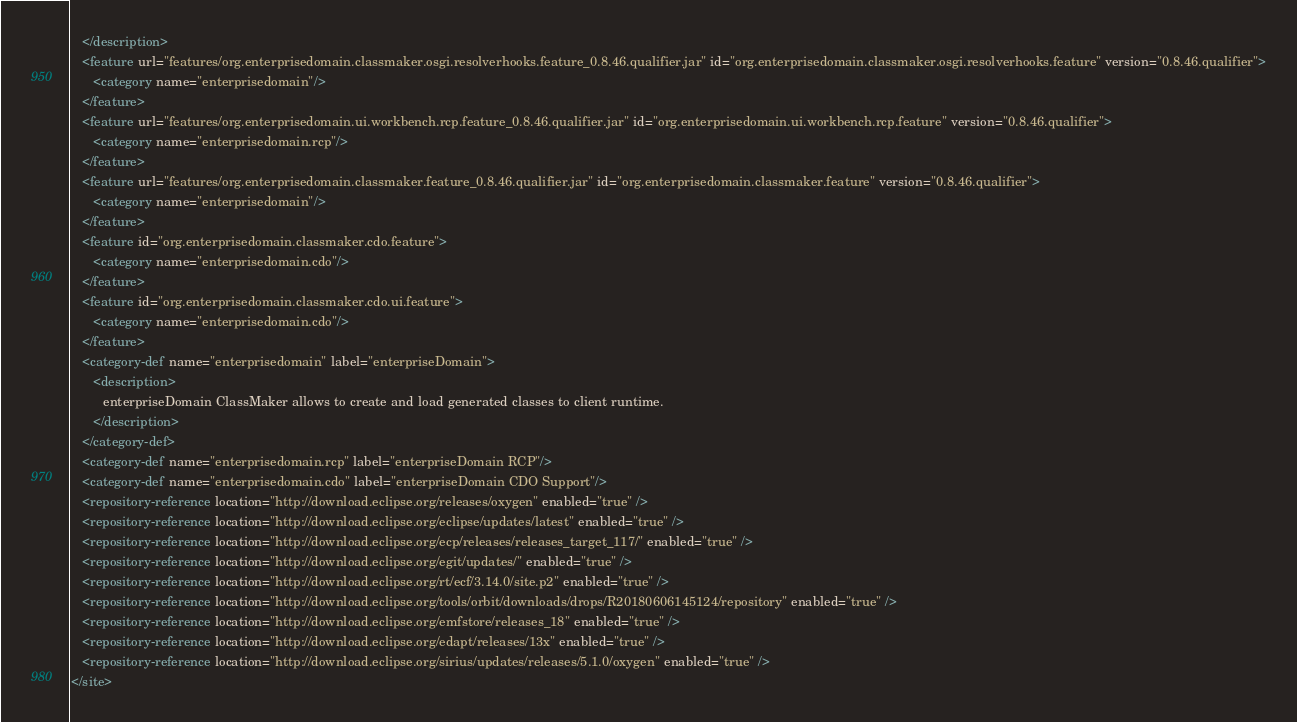Convert code to text. <code><loc_0><loc_0><loc_500><loc_500><_XML_>   </description>
   <feature url="features/org.enterprisedomain.classmaker.osgi.resolverhooks.feature_0.8.46.qualifier.jar" id="org.enterprisedomain.classmaker.osgi.resolverhooks.feature" version="0.8.46.qualifier">
      <category name="enterprisedomain"/>
   </feature>
   <feature url="features/org.enterprisedomain.ui.workbench.rcp.feature_0.8.46.qualifier.jar" id="org.enterprisedomain.ui.workbench.rcp.feature" version="0.8.46.qualifier">
      <category name="enterprisedomain.rcp"/>
   </feature>
   <feature url="features/org.enterprisedomain.classmaker.feature_0.8.46.qualifier.jar" id="org.enterprisedomain.classmaker.feature" version="0.8.46.qualifier">
      <category name="enterprisedomain"/>
   </feature>
   <feature id="org.enterprisedomain.classmaker.cdo.feature">
      <category name="enterprisedomain.cdo"/>
   </feature>
   <feature id="org.enterprisedomain.classmaker.cdo.ui.feature">
      <category name="enterprisedomain.cdo"/>
   </feature>
   <category-def name="enterprisedomain" label="enterpriseDomain">
      <description>
         enterpriseDomain ClassMaker allows to create and load generated classes to client runtime.
      </description>
   </category-def>
   <category-def name="enterprisedomain.rcp" label="enterpriseDomain RCP"/>
   <category-def name="enterprisedomain.cdo" label="enterpriseDomain CDO Support"/>
   <repository-reference location="http://download.eclipse.org/releases/oxygen" enabled="true" />
   <repository-reference location="http://download.eclipse.org/eclipse/updates/latest" enabled="true" />
   <repository-reference location="http://download.eclipse.org/ecp/releases/releases_target_117/" enabled="true" />
   <repository-reference location="http://download.eclipse.org/egit/updates/" enabled="true" />
   <repository-reference location="http://download.eclipse.org/rt/ecf/3.14.0/site.p2" enabled="true" />
   <repository-reference location="http://download.eclipse.org/tools/orbit/downloads/drops/R20180606145124/repository" enabled="true" />
   <repository-reference location="http://download.eclipse.org/emfstore/releases_18" enabled="true" />
   <repository-reference location="http://download.eclipse.org/edapt/releases/13x" enabled="true" />
   <repository-reference location="http://download.eclipse.org/sirius/updates/releases/5.1.0/oxygen" enabled="true" />
</site>
</code> 